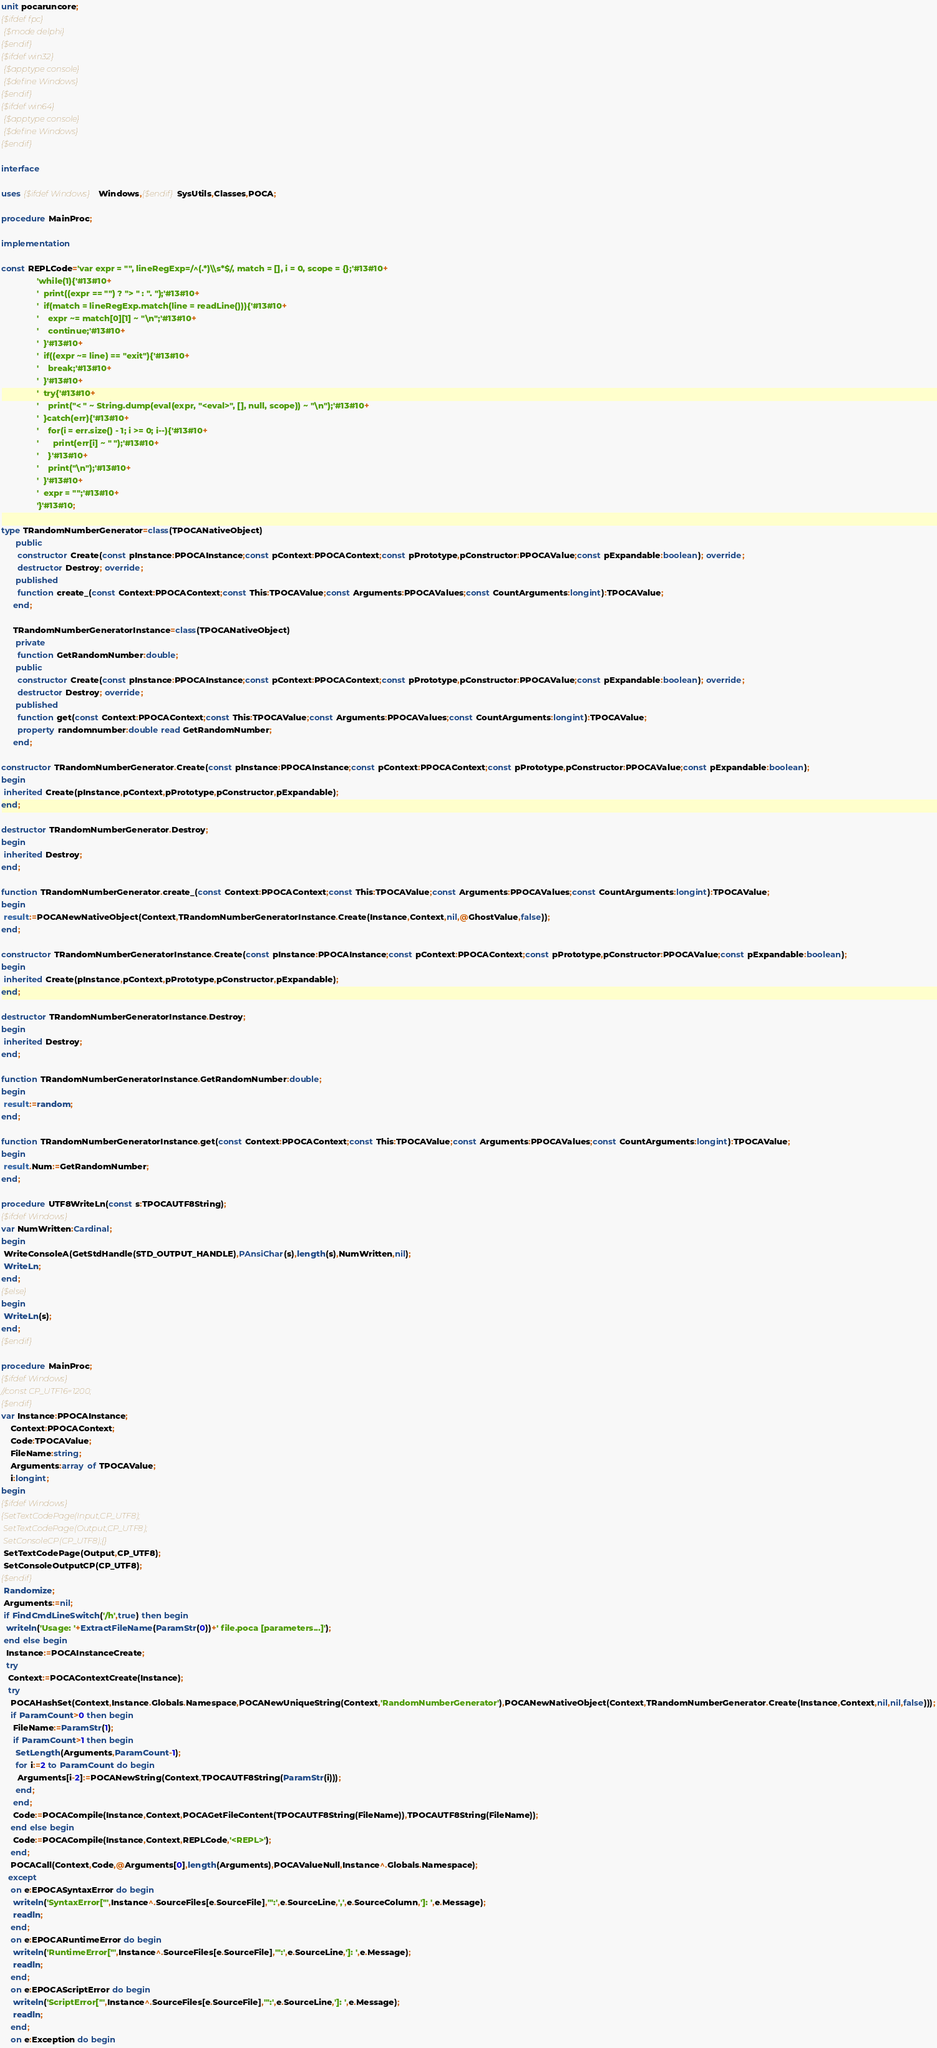Convert code to text. <code><loc_0><loc_0><loc_500><loc_500><_Pascal_>unit pocaruncore;
{$ifdef fpc}
 {$mode delphi}
{$endif}
{$ifdef win32}
 {$apptype console}
 {$define Windows}
{$endif}
{$ifdef win64}
 {$apptype console}
 {$define Windows}
{$endif}

interface

uses {$ifdef Windows}Windows,{$endif}SysUtils,Classes,POCA;

procedure MainProc;

implementation

const REPLCode='var expr = "", lineRegExp=/^(.*)\\s*$/, match = [], i = 0, scope = {};'#13#10+
               'while(1){'#13#10+
               '  print((expr == "") ? "> " : ". ");'#13#10+
               '  if(match = lineRegExp.match(line = readLine())){'#13#10+
               '    expr ~= match[0][1] ~ "\n";'#13#10+
               '    continue;'#13#10+
               '  }'#13#10+
               '  if((expr ~= line) == "exit"){'#13#10+
               '    break;'#13#10+
               '  }'#13#10+
               '  try{'#13#10+
               '    print("< " ~ String.dump(eval(expr, "<eval>", [], null, scope)) ~ "\n");'#13#10+
               '  }catch(err){'#13#10+
               '    for(i = err.size() - 1; i >= 0; i--){'#13#10+
               '      print(err[i] ~ " ");'#13#10+
               '    }'#13#10+
               '    print("\n");'#13#10+
               '  }'#13#10+
               '  expr = "";'#13#10+
               '}'#13#10;

type TRandomNumberGenerator=class(TPOCANativeObject)
      public
       constructor Create(const pInstance:PPOCAInstance;const pContext:PPOCAContext;const pPrototype,pConstructor:PPOCAValue;const pExpandable:boolean); override;
       destructor Destroy; override;
      published
       function create_(const Context:PPOCAContext;const This:TPOCAValue;const Arguments:PPOCAValues;const CountArguments:longint):TPOCAValue;
     end;

     TRandomNumberGeneratorInstance=class(TPOCANativeObject)
      private
       function GetRandomNumber:double;
      public
       constructor Create(const pInstance:PPOCAInstance;const pContext:PPOCAContext;const pPrototype,pConstructor:PPOCAValue;const pExpandable:boolean); override;
       destructor Destroy; override;
      published
       function get(const Context:PPOCAContext;const This:TPOCAValue;const Arguments:PPOCAValues;const CountArguments:longint):TPOCAValue;
       property randomnumber:double read GetRandomNumber;
     end;

constructor TRandomNumberGenerator.Create(const pInstance:PPOCAInstance;const pContext:PPOCAContext;const pPrototype,pConstructor:PPOCAValue;const pExpandable:boolean);
begin
 inherited Create(pInstance,pContext,pPrototype,pConstructor,pExpandable);
end;

destructor TRandomNumberGenerator.Destroy;
begin
 inherited Destroy;
end;

function TRandomNumberGenerator.create_(const Context:PPOCAContext;const This:TPOCAValue;const Arguments:PPOCAValues;const CountArguments:longint):TPOCAValue;
begin
 result:=POCANewNativeObject(Context,TRandomNumberGeneratorInstance.Create(Instance,Context,nil,@GhostValue,false));
end;

constructor TRandomNumberGeneratorInstance.Create(const pInstance:PPOCAInstance;const pContext:PPOCAContext;const pPrototype,pConstructor:PPOCAValue;const pExpandable:boolean);
begin
 inherited Create(pInstance,pContext,pPrototype,pConstructor,pExpandable);
end;

destructor TRandomNumberGeneratorInstance.Destroy;
begin
 inherited Destroy;
end;

function TRandomNumberGeneratorInstance.GetRandomNumber:double;
begin
 result:=random;
end;

function TRandomNumberGeneratorInstance.get(const Context:PPOCAContext;const This:TPOCAValue;const Arguments:PPOCAValues;const CountArguments:longint):TPOCAValue;
begin
 result.Num:=GetRandomNumber;
end;

procedure UTF8WriteLn(const s:TPOCAUTF8String);
{$ifdef Windows}
var NumWritten:Cardinal;
begin
 WriteConsoleA(GetStdHandle(STD_OUTPUT_HANDLE),PAnsiChar(s),length(s),NumWritten,nil);
 WriteLn;
end;
{$else}
begin
 WriteLn(s);
end;
{$endif}

procedure MainProc;
{$ifdef Windows}
//const CP_UTF16=1200;
{$endif}
var Instance:PPOCAInstance;
    Context:PPOCAContext;
    Code:TPOCAValue;
    FileName:string;
    Arguments:array of TPOCAValue;
    i:longint;
begin
{$ifdef Windows}
{SetTextCodePage(Input,CP_UTF8);
 SetTextCodePage(Output,CP_UTF8);
 SetConsoleCP(CP_UTF8);{}
 SetTextCodePage(Output,CP_UTF8);
 SetConsoleOutputCP(CP_UTF8);
{$endif}
 Randomize;
 Arguments:=nil;
 if FindCmdLineSwitch('/h',true) then begin
  writeln('Usage: '+ExtractFileName(ParamStr(0))+' file.poca [parameters...]');
 end else begin
  Instance:=POCAInstanceCreate;
  try
   Context:=POCAContextCreate(Instance);
   try
    POCAHashSet(Context,Instance.Globals.Namespace,POCANewUniqueString(Context,'RandomNumberGenerator'),POCANewNativeObject(Context,TRandomNumberGenerator.Create(Instance,Context,nil,nil,false)));
    if ParamCount>0 then begin
     FileName:=ParamStr(1);
     if ParamCount>1 then begin
      SetLength(Arguments,ParamCount-1);
      for i:=2 to ParamCount do begin
       Arguments[i-2]:=POCANewString(Context,TPOCAUTF8String(ParamStr(i)));
      end;
     end;
     Code:=POCACompile(Instance,Context,POCAGetFileContent(TPOCAUTF8String(FileName)),TPOCAUTF8String(FileName));
    end else begin
     Code:=POCACompile(Instance,Context,REPLCode,'<REPL>');
    end;
    POCACall(Context,Code,@Arguments[0],length(Arguments),POCAValueNull,Instance^.Globals.Namespace);
   except
    on e:EPOCASyntaxError do begin
     writeln('SyntaxError["',Instance^.SourceFiles[e.SourceFile],'":',e.SourceLine,',',e.SourceColumn,']: ',e.Message);
     readln;
    end;
    on e:EPOCARuntimeError do begin
     writeln('RuntimeError["',Instance^.SourceFiles[e.SourceFile],'":',e.SourceLine,']: ',e.Message);
     readln;
    end;
    on e:EPOCAScriptError do begin
     writeln('ScriptError["',Instance^.SourceFiles[e.SourceFile],'":',e.SourceLine,']: ',e.Message);
     readln;
    end;
    on e:Exception do begin</code> 